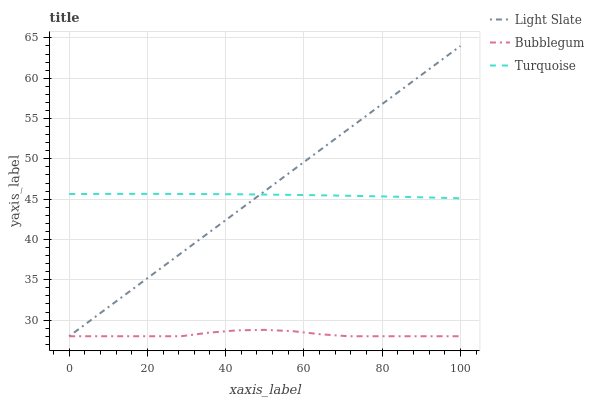Does Bubblegum have the minimum area under the curve?
Answer yes or no. Yes. Does Light Slate have the maximum area under the curve?
Answer yes or no. Yes. Does Turquoise have the minimum area under the curve?
Answer yes or no. No. Does Turquoise have the maximum area under the curve?
Answer yes or no. No. Is Light Slate the smoothest?
Answer yes or no. Yes. Is Bubblegum the roughest?
Answer yes or no. Yes. Is Turquoise the smoothest?
Answer yes or no. No. Is Turquoise the roughest?
Answer yes or no. No. Does Light Slate have the lowest value?
Answer yes or no. Yes. Does Turquoise have the lowest value?
Answer yes or no. No. Does Light Slate have the highest value?
Answer yes or no. Yes. Does Turquoise have the highest value?
Answer yes or no. No. Is Bubblegum less than Turquoise?
Answer yes or no. Yes. Is Turquoise greater than Bubblegum?
Answer yes or no. Yes. Does Bubblegum intersect Light Slate?
Answer yes or no. Yes. Is Bubblegum less than Light Slate?
Answer yes or no. No. Is Bubblegum greater than Light Slate?
Answer yes or no. No. Does Bubblegum intersect Turquoise?
Answer yes or no. No. 